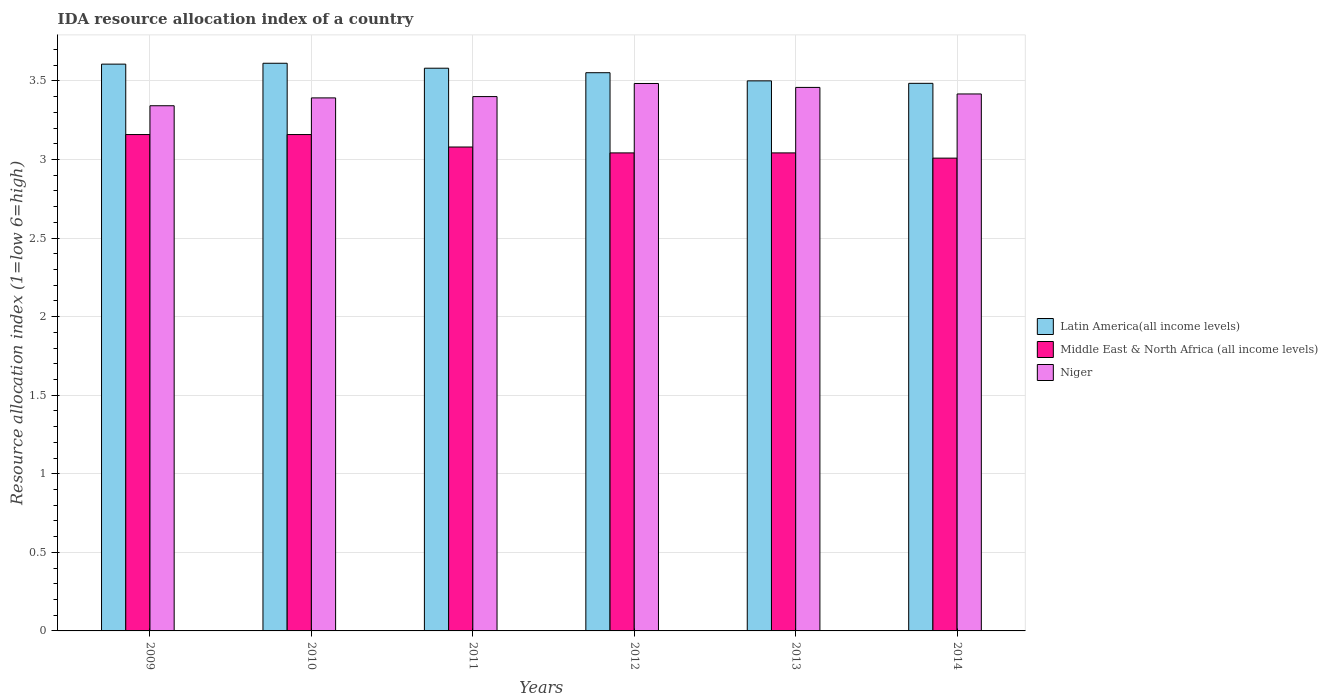How many groups of bars are there?
Offer a very short reply. 6. How many bars are there on the 1st tick from the right?
Provide a short and direct response. 3. What is the label of the 6th group of bars from the left?
Your response must be concise. 2014. In how many cases, is the number of bars for a given year not equal to the number of legend labels?
Ensure brevity in your answer.  0. What is the IDA resource allocation index in Middle East & North Africa (all income levels) in 2010?
Offer a terse response. 3.16. Across all years, what is the maximum IDA resource allocation index in Latin America(all income levels)?
Your answer should be very brief. 3.61. Across all years, what is the minimum IDA resource allocation index in Middle East & North Africa (all income levels)?
Ensure brevity in your answer.  3.01. In which year was the IDA resource allocation index in Latin America(all income levels) maximum?
Provide a succinct answer. 2010. In which year was the IDA resource allocation index in Niger minimum?
Ensure brevity in your answer.  2009. What is the total IDA resource allocation index in Niger in the graph?
Make the answer very short. 20.49. What is the difference between the IDA resource allocation index in Middle East & North Africa (all income levels) in 2009 and that in 2011?
Ensure brevity in your answer.  0.08. What is the difference between the IDA resource allocation index in Latin America(all income levels) in 2014 and the IDA resource allocation index in Middle East & North Africa (all income levels) in 2012?
Make the answer very short. 0.44. What is the average IDA resource allocation index in Middle East & North Africa (all income levels) per year?
Your answer should be very brief. 3.08. In the year 2013, what is the difference between the IDA resource allocation index in Latin America(all income levels) and IDA resource allocation index in Niger?
Keep it short and to the point. 0.04. What is the ratio of the IDA resource allocation index in Niger in 2011 to that in 2012?
Make the answer very short. 0.98. Is the IDA resource allocation index in Niger in 2010 less than that in 2011?
Make the answer very short. Yes. What is the difference between the highest and the second highest IDA resource allocation index in Latin America(all income levels)?
Make the answer very short. 0.01. What is the difference between the highest and the lowest IDA resource allocation index in Niger?
Provide a short and direct response. 0.14. In how many years, is the IDA resource allocation index in Niger greater than the average IDA resource allocation index in Niger taken over all years?
Provide a short and direct response. 3. Is the sum of the IDA resource allocation index in Niger in 2009 and 2013 greater than the maximum IDA resource allocation index in Latin America(all income levels) across all years?
Make the answer very short. Yes. What does the 1st bar from the left in 2009 represents?
Give a very brief answer. Latin America(all income levels). What does the 2nd bar from the right in 2013 represents?
Give a very brief answer. Middle East & North Africa (all income levels). How many years are there in the graph?
Provide a short and direct response. 6. Are the values on the major ticks of Y-axis written in scientific E-notation?
Keep it short and to the point. No. Does the graph contain any zero values?
Give a very brief answer. No. Where does the legend appear in the graph?
Provide a short and direct response. Center right. How many legend labels are there?
Provide a succinct answer. 3. How are the legend labels stacked?
Your response must be concise. Vertical. What is the title of the graph?
Offer a very short reply. IDA resource allocation index of a country. Does "Sub-Saharan Africa (all income levels)" appear as one of the legend labels in the graph?
Offer a terse response. No. What is the label or title of the Y-axis?
Your answer should be compact. Resource allocation index (1=low 6=high). What is the Resource allocation index (1=low 6=high) in Latin America(all income levels) in 2009?
Your response must be concise. 3.61. What is the Resource allocation index (1=low 6=high) in Middle East & North Africa (all income levels) in 2009?
Offer a very short reply. 3.16. What is the Resource allocation index (1=low 6=high) of Niger in 2009?
Offer a terse response. 3.34. What is the Resource allocation index (1=low 6=high) in Latin America(all income levels) in 2010?
Keep it short and to the point. 3.61. What is the Resource allocation index (1=low 6=high) of Middle East & North Africa (all income levels) in 2010?
Your response must be concise. 3.16. What is the Resource allocation index (1=low 6=high) in Niger in 2010?
Give a very brief answer. 3.39. What is the Resource allocation index (1=low 6=high) in Latin America(all income levels) in 2011?
Offer a terse response. 3.58. What is the Resource allocation index (1=low 6=high) of Middle East & North Africa (all income levels) in 2011?
Make the answer very short. 3.08. What is the Resource allocation index (1=low 6=high) of Niger in 2011?
Your response must be concise. 3.4. What is the Resource allocation index (1=low 6=high) of Latin America(all income levels) in 2012?
Provide a succinct answer. 3.55. What is the Resource allocation index (1=low 6=high) of Middle East & North Africa (all income levels) in 2012?
Provide a short and direct response. 3.04. What is the Resource allocation index (1=low 6=high) in Niger in 2012?
Offer a terse response. 3.48. What is the Resource allocation index (1=low 6=high) in Middle East & North Africa (all income levels) in 2013?
Offer a very short reply. 3.04. What is the Resource allocation index (1=low 6=high) of Niger in 2013?
Your answer should be compact. 3.46. What is the Resource allocation index (1=low 6=high) in Latin America(all income levels) in 2014?
Keep it short and to the point. 3.48. What is the Resource allocation index (1=low 6=high) in Middle East & North Africa (all income levels) in 2014?
Your response must be concise. 3.01. What is the Resource allocation index (1=low 6=high) of Niger in 2014?
Keep it short and to the point. 3.42. Across all years, what is the maximum Resource allocation index (1=low 6=high) in Latin America(all income levels)?
Make the answer very short. 3.61. Across all years, what is the maximum Resource allocation index (1=low 6=high) in Middle East & North Africa (all income levels)?
Provide a short and direct response. 3.16. Across all years, what is the maximum Resource allocation index (1=low 6=high) of Niger?
Offer a terse response. 3.48. Across all years, what is the minimum Resource allocation index (1=low 6=high) in Latin America(all income levels)?
Your answer should be compact. 3.48. Across all years, what is the minimum Resource allocation index (1=low 6=high) in Middle East & North Africa (all income levels)?
Your response must be concise. 3.01. Across all years, what is the minimum Resource allocation index (1=low 6=high) of Niger?
Your response must be concise. 3.34. What is the total Resource allocation index (1=low 6=high) in Latin America(all income levels) in the graph?
Your answer should be compact. 21.34. What is the total Resource allocation index (1=low 6=high) of Middle East & North Africa (all income levels) in the graph?
Offer a terse response. 18.49. What is the total Resource allocation index (1=low 6=high) in Niger in the graph?
Keep it short and to the point. 20.49. What is the difference between the Resource allocation index (1=low 6=high) in Latin America(all income levels) in 2009 and that in 2010?
Keep it short and to the point. -0.01. What is the difference between the Resource allocation index (1=low 6=high) in Middle East & North Africa (all income levels) in 2009 and that in 2010?
Offer a terse response. 0. What is the difference between the Resource allocation index (1=low 6=high) in Niger in 2009 and that in 2010?
Ensure brevity in your answer.  -0.05. What is the difference between the Resource allocation index (1=low 6=high) in Latin America(all income levels) in 2009 and that in 2011?
Provide a succinct answer. 0.03. What is the difference between the Resource allocation index (1=low 6=high) of Middle East & North Africa (all income levels) in 2009 and that in 2011?
Your response must be concise. 0.08. What is the difference between the Resource allocation index (1=low 6=high) in Niger in 2009 and that in 2011?
Give a very brief answer. -0.06. What is the difference between the Resource allocation index (1=low 6=high) in Latin America(all income levels) in 2009 and that in 2012?
Give a very brief answer. 0.05. What is the difference between the Resource allocation index (1=low 6=high) in Middle East & North Africa (all income levels) in 2009 and that in 2012?
Offer a terse response. 0.12. What is the difference between the Resource allocation index (1=low 6=high) in Niger in 2009 and that in 2012?
Your response must be concise. -0.14. What is the difference between the Resource allocation index (1=low 6=high) of Latin America(all income levels) in 2009 and that in 2013?
Ensure brevity in your answer.  0.11. What is the difference between the Resource allocation index (1=low 6=high) in Middle East & North Africa (all income levels) in 2009 and that in 2013?
Provide a short and direct response. 0.12. What is the difference between the Resource allocation index (1=low 6=high) of Niger in 2009 and that in 2013?
Your answer should be very brief. -0.12. What is the difference between the Resource allocation index (1=low 6=high) of Latin America(all income levels) in 2009 and that in 2014?
Your answer should be compact. 0.12. What is the difference between the Resource allocation index (1=low 6=high) of Middle East & North Africa (all income levels) in 2009 and that in 2014?
Offer a very short reply. 0.15. What is the difference between the Resource allocation index (1=low 6=high) in Niger in 2009 and that in 2014?
Offer a very short reply. -0.07. What is the difference between the Resource allocation index (1=low 6=high) in Latin America(all income levels) in 2010 and that in 2011?
Make the answer very short. 0.03. What is the difference between the Resource allocation index (1=low 6=high) of Middle East & North Africa (all income levels) in 2010 and that in 2011?
Give a very brief answer. 0.08. What is the difference between the Resource allocation index (1=low 6=high) in Niger in 2010 and that in 2011?
Give a very brief answer. -0.01. What is the difference between the Resource allocation index (1=low 6=high) of Latin America(all income levels) in 2010 and that in 2012?
Provide a succinct answer. 0.06. What is the difference between the Resource allocation index (1=low 6=high) of Middle East & North Africa (all income levels) in 2010 and that in 2012?
Make the answer very short. 0.12. What is the difference between the Resource allocation index (1=low 6=high) of Niger in 2010 and that in 2012?
Your response must be concise. -0.09. What is the difference between the Resource allocation index (1=low 6=high) in Latin America(all income levels) in 2010 and that in 2013?
Ensure brevity in your answer.  0.11. What is the difference between the Resource allocation index (1=low 6=high) in Middle East & North Africa (all income levels) in 2010 and that in 2013?
Ensure brevity in your answer.  0.12. What is the difference between the Resource allocation index (1=low 6=high) in Niger in 2010 and that in 2013?
Your response must be concise. -0.07. What is the difference between the Resource allocation index (1=low 6=high) in Latin America(all income levels) in 2010 and that in 2014?
Your response must be concise. 0.13. What is the difference between the Resource allocation index (1=low 6=high) in Middle East & North Africa (all income levels) in 2010 and that in 2014?
Give a very brief answer. 0.15. What is the difference between the Resource allocation index (1=low 6=high) in Niger in 2010 and that in 2014?
Your response must be concise. -0.03. What is the difference between the Resource allocation index (1=low 6=high) of Latin America(all income levels) in 2011 and that in 2012?
Your answer should be compact. 0.03. What is the difference between the Resource allocation index (1=low 6=high) of Middle East & North Africa (all income levels) in 2011 and that in 2012?
Offer a very short reply. 0.04. What is the difference between the Resource allocation index (1=low 6=high) in Niger in 2011 and that in 2012?
Your answer should be very brief. -0.08. What is the difference between the Resource allocation index (1=low 6=high) in Latin America(all income levels) in 2011 and that in 2013?
Offer a terse response. 0.08. What is the difference between the Resource allocation index (1=low 6=high) of Middle East & North Africa (all income levels) in 2011 and that in 2013?
Your answer should be compact. 0.04. What is the difference between the Resource allocation index (1=low 6=high) in Niger in 2011 and that in 2013?
Your answer should be very brief. -0.06. What is the difference between the Resource allocation index (1=low 6=high) in Latin America(all income levels) in 2011 and that in 2014?
Provide a succinct answer. 0.1. What is the difference between the Resource allocation index (1=low 6=high) of Middle East & North Africa (all income levels) in 2011 and that in 2014?
Ensure brevity in your answer.  0.07. What is the difference between the Resource allocation index (1=low 6=high) of Niger in 2011 and that in 2014?
Provide a succinct answer. -0.02. What is the difference between the Resource allocation index (1=low 6=high) in Latin America(all income levels) in 2012 and that in 2013?
Give a very brief answer. 0.05. What is the difference between the Resource allocation index (1=low 6=high) in Niger in 2012 and that in 2013?
Your answer should be compact. 0.03. What is the difference between the Resource allocation index (1=low 6=high) in Latin America(all income levels) in 2012 and that in 2014?
Make the answer very short. 0.07. What is the difference between the Resource allocation index (1=low 6=high) of Middle East & North Africa (all income levels) in 2012 and that in 2014?
Your response must be concise. 0.03. What is the difference between the Resource allocation index (1=low 6=high) of Niger in 2012 and that in 2014?
Offer a terse response. 0.07. What is the difference between the Resource allocation index (1=low 6=high) in Latin America(all income levels) in 2013 and that in 2014?
Keep it short and to the point. 0.02. What is the difference between the Resource allocation index (1=low 6=high) of Middle East & North Africa (all income levels) in 2013 and that in 2014?
Your answer should be compact. 0.03. What is the difference between the Resource allocation index (1=low 6=high) in Niger in 2013 and that in 2014?
Your answer should be very brief. 0.04. What is the difference between the Resource allocation index (1=low 6=high) of Latin America(all income levels) in 2009 and the Resource allocation index (1=low 6=high) of Middle East & North Africa (all income levels) in 2010?
Make the answer very short. 0.45. What is the difference between the Resource allocation index (1=low 6=high) in Latin America(all income levels) in 2009 and the Resource allocation index (1=low 6=high) in Niger in 2010?
Ensure brevity in your answer.  0.21. What is the difference between the Resource allocation index (1=low 6=high) of Middle East & North Africa (all income levels) in 2009 and the Resource allocation index (1=low 6=high) of Niger in 2010?
Keep it short and to the point. -0.23. What is the difference between the Resource allocation index (1=low 6=high) in Latin America(all income levels) in 2009 and the Resource allocation index (1=low 6=high) in Middle East & North Africa (all income levels) in 2011?
Make the answer very short. 0.53. What is the difference between the Resource allocation index (1=low 6=high) of Latin America(all income levels) in 2009 and the Resource allocation index (1=low 6=high) of Niger in 2011?
Your answer should be very brief. 0.21. What is the difference between the Resource allocation index (1=low 6=high) in Middle East & North Africa (all income levels) in 2009 and the Resource allocation index (1=low 6=high) in Niger in 2011?
Make the answer very short. -0.24. What is the difference between the Resource allocation index (1=low 6=high) in Latin America(all income levels) in 2009 and the Resource allocation index (1=low 6=high) in Middle East & North Africa (all income levels) in 2012?
Offer a terse response. 0.56. What is the difference between the Resource allocation index (1=low 6=high) of Latin America(all income levels) in 2009 and the Resource allocation index (1=low 6=high) of Niger in 2012?
Offer a terse response. 0.12. What is the difference between the Resource allocation index (1=low 6=high) of Middle East & North Africa (all income levels) in 2009 and the Resource allocation index (1=low 6=high) of Niger in 2012?
Make the answer very short. -0.33. What is the difference between the Resource allocation index (1=low 6=high) of Latin America(all income levels) in 2009 and the Resource allocation index (1=low 6=high) of Middle East & North Africa (all income levels) in 2013?
Offer a terse response. 0.56. What is the difference between the Resource allocation index (1=low 6=high) in Latin America(all income levels) in 2009 and the Resource allocation index (1=low 6=high) in Niger in 2013?
Make the answer very short. 0.15. What is the difference between the Resource allocation index (1=low 6=high) in Latin America(all income levels) in 2009 and the Resource allocation index (1=low 6=high) in Middle East & North Africa (all income levels) in 2014?
Offer a very short reply. 0.6. What is the difference between the Resource allocation index (1=low 6=high) in Latin America(all income levels) in 2009 and the Resource allocation index (1=low 6=high) in Niger in 2014?
Offer a terse response. 0.19. What is the difference between the Resource allocation index (1=low 6=high) of Middle East & North Africa (all income levels) in 2009 and the Resource allocation index (1=low 6=high) of Niger in 2014?
Your answer should be very brief. -0.26. What is the difference between the Resource allocation index (1=low 6=high) of Latin America(all income levels) in 2010 and the Resource allocation index (1=low 6=high) of Middle East & North Africa (all income levels) in 2011?
Your answer should be compact. 0.53. What is the difference between the Resource allocation index (1=low 6=high) of Latin America(all income levels) in 2010 and the Resource allocation index (1=low 6=high) of Niger in 2011?
Offer a terse response. 0.21. What is the difference between the Resource allocation index (1=low 6=high) of Middle East & North Africa (all income levels) in 2010 and the Resource allocation index (1=low 6=high) of Niger in 2011?
Your response must be concise. -0.24. What is the difference between the Resource allocation index (1=low 6=high) in Latin America(all income levels) in 2010 and the Resource allocation index (1=low 6=high) in Middle East & North Africa (all income levels) in 2012?
Make the answer very short. 0.57. What is the difference between the Resource allocation index (1=low 6=high) of Latin America(all income levels) in 2010 and the Resource allocation index (1=low 6=high) of Niger in 2012?
Offer a terse response. 0.13. What is the difference between the Resource allocation index (1=low 6=high) in Middle East & North Africa (all income levels) in 2010 and the Resource allocation index (1=low 6=high) in Niger in 2012?
Give a very brief answer. -0.33. What is the difference between the Resource allocation index (1=low 6=high) in Latin America(all income levels) in 2010 and the Resource allocation index (1=low 6=high) in Middle East & North Africa (all income levels) in 2013?
Your answer should be compact. 0.57. What is the difference between the Resource allocation index (1=low 6=high) of Latin America(all income levels) in 2010 and the Resource allocation index (1=low 6=high) of Niger in 2013?
Your response must be concise. 0.15. What is the difference between the Resource allocation index (1=low 6=high) in Latin America(all income levels) in 2010 and the Resource allocation index (1=low 6=high) in Middle East & North Africa (all income levels) in 2014?
Give a very brief answer. 0.6. What is the difference between the Resource allocation index (1=low 6=high) of Latin America(all income levels) in 2010 and the Resource allocation index (1=low 6=high) of Niger in 2014?
Keep it short and to the point. 0.2. What is the difference between the Resource allocation index (1=low 6=high) in Middle East & North Africa (all income levels) in 2010 and the Resource allocation index (1=low 6=high) in Niger in 2014?
Provide a short and direct response. -0.26. What is the difference between the Resource allocation index (1=low 6=high) of Latin America(all income levels) in 2011 and the Resource allocation index (1=low 6=high) of Middle East & North Africa (all income levels) in 2012?
Your response must be concise. 0.54. What is the difference between the Resource allocation index (1=low 6=high) in Latin America(all income levels) in 2011 and the Resource allocation index (1=low 6=high) in Niger in 2012?
Your answer should be compact. 0.1. What is the difference between the Resource allocation index (1=low 6=high) of Middle East & North Africa (all income levels) in 2011 and the Resource allocation index (1=low 6=high) of Niger in 2012?
Give a very brief answer. -0.4. What is the difference between the Resource allocation index (1=low 6=high) of Latin America(all income levels) in 2011 and the Resource allocation index (1=low 6=high) of Middle East & North Africa (all income levels) in 2013?
Ensure brevity in your answer.  0.54. What is the difference between the Resource allocation index (1=low 6=high) of Latin America(all income levels) in 2011 and the Resource allocation index (1=low 6=high) of Niger in 2013?
Ensure brevity in your answer.  0.12. What is the difference between the Resource allocation index (1=low 6=high) in Middle East & North Africa (all income levels) in 2011 and the Resource allocation index (1=low 6=high) in Niger in 2013?
Keep it short and to the point. -0.38. What is the difference between the Resource allocation index (1=low 6=high) in Latin America(all income levels) in 2011 and the Resource allocation index (1=low 6=high) in Middle East & North Africa (all income levels) in 2014?
Give a very brief answer. 0.57. What is the difference between the Resource allocation index (1=low 6=high) of Latin America(all income levels) in 2011 and the Resource allocation index (1=low 6=high) of Niger in 2014?
Provide a succinct answer. 0.16. What is the difference between the Resource allocation index (1=low 6=high) in Middle East & North Africa (all income levels) in 2011 and the Resource allocation index (1=low 6=high) in Niger in 2014?
Give a very brief answer. -0.34. What is the difference between the Resource allocation index (1=low 6=high) in Latin America(all income levels) in 2012 and the Resource allocation index (1=low 6=high) in Middle East & North Africa (all income levels) in 2013?
Keep it short and to the point. 0.51. What is the difference between the Resource allocation index (1=low 6=high) of Latin America(all income levels) in 2012 and the Resource allocation index (1=low 6=high) of Niger in 2013?
Provide a succinct answer. 0.09. What is the difference between the Resource allocation index (1=low 6=high) of Middle East & North Africa (all income levels) in 2012 and the Resource allocation index (1=low 6=high) of Niger in 2013?
Your answer should be compact. -0.42. What is the difference between the Resource allocation index (1=low 6=high) in Latin America(all income levels) in 2012 and the Resource allocation index (1=low 6=high) in Middle East & North Africa (all income levels) in 2014?
Your response must be concise. 0.54. What is the difference between the Resource allocation index (1=low 6=high) of Latin America(all income levels) in 2012 and the Resource allocation index (1=low 6=high) of Niger in 2014?
Ensure brevity in your answer.  0.14. What is the difference between the Resource allocation index (1=low 6=high) in Middle East & North Africa (all income levels) in 2012 and the Resource allocation index (1=low 6=high) in Niger in 2014?
Ensure brevity in your answer.  -0.38. What is the difference between the Resource allocation index (1=low 6=high) in Latin America(all income levels) in 2013 and the Resource allocation index (1=low 6=high) in Middle East & North Africa (all income levels) in 2014?
Provide a succinct answer. 0.49. What is the difference between the Resource allocation index (1=low 6=high) in Latin America(all income levels) in 2013 and the Resource allocation index (1=low 6=high) in Niger in 2014?
Provide a short and direct response. 0.08. What is the difference between the Resource allocation index (1=low 6=high) in Middle East & North Africa (all income levels) in 2013 and the Resource allocation index (1=low 6=high) in Niger in 2014?
Your answer should be compact. -0.38. What is the average Resource allocation index (1=low 6=high) in Latin America(all income levels) per year?
Keep it short and to the point. 3.56. What is the average Resource allocation index (1=low 6=high) in Middle East & North Africa (all income levels) per year?
Keep it short and to the point. 3.08. What is the average Resource allocation index (1=low 6=high) of Niger per year?
Your answer should be very brief. 3.42. In the year 2009, what is the difference between the Resource allocation index (1=low 6=high) of Latin America(all income levels) and Resource allocation index (1=low 6=high) of Middle East & North Africa (all income levels)?
Give a very brief answer. 0.45. In the year 2009, what is the difference between the Resource allocation index (1=low 6=high) in Latin America(all income levels) and Resource allocation index (1=low 6=high) in Niger?
Offer a very short reply. 0.26. In the year 2009, what is the difference between the Resource allocation index (1=low 6=high) of Middle East & North Africa (all income levels) and Resource allocation index (1=low 6=high) of Niger?
Offer a terse response. -0.18. In the year 2010, what is the difference between the Resource allocation index (1=low 6=high) of Latin America(all income levels) and Resource allocation index (1=low 6=high) of Middle East & North Africa (all income levels)?
Provide a succinct answer. 0.45. In the year 2010, what is the difference between the Resource allocation index (1=low 6=high) in Latin America(all income levels) and Resource allocation index (1=low 6=high) in Niger?
Ensure brevity in your answer.  0.22. In the year 2010, what is the difference between the Resource allocation index (1=low 6=high) of Middle East & North Africa (all income levels) and Resource allocation index (1=low 6=high) of Niger?
Provide a short and direct response. -0.23. In the year 2011, what is the difference between the Resource allocation index (1=low 6=high) of Latin America(all income levels) and Resource allocation index (1=low 6=high) of Middle East & North Africa (all income levels)?
Keep it short and to the point. 0.5. In the year 2011, what is the difference between the Resource allocation index (1=low 6=high) in Latin America(all income levels) and Resource allocation index (1=low 6=high) in Niger?
Provide a succinct answer. 0.18. In the year 2011, what is the difference between the Resource allocation index (1=low 6=high) in Middle East & North Africa (all income levels) and Resource allocation index (1=low 6=high) in Niger?
Your answer should be compact. -0.32. In the year 2012, what is the difference between the Resource allocation index (1=low 6=high) of Latin America(all income levels) and Resource allocation index (1=low 6=high) of Middle East & North Africa (all income levels)?
Provide a short and direct response. 0.51. In the year 2012, what is the difference between the Resource allocation index (1=low 6=high) in Latin America(all income levels) and Resource allocation index (1=low 6=high) in Niger?
Make the answer very short. 0.07. In the year 2012, what is the difference between the Resource allocation index (1=low 6=high) of Middle East & North Africa (all income levels) and Resource allocation index (1=low 6=high) of Niger?
Offer a terse response. -0.44. In the year 2013, what is the difference between the Resource allocation index (1=low 6=high) of Latin America(all income levels) and Resource allocation index (1=low 6=high) of Middle East & North Africa (all income levels)?
Ensure brevity in your answer.  0.46. In the year 2013, what is the difference between the Resource allocation index (1=low 6=high) in Latin America(all income levels) and Resource allocation index (1=low 6=high) in Niger?
Keep it short and to the point. 0.04. In the year 2013, what is the difference between the Resource allocation index (1=low 6=high) in Middle East & North Africa (all income levels) and Resource allocation index (1=low 6=high) in Niger?
Give a very brief answer. -0.42. In the year 2014, what is the difference between the Resource allocation index (1=low 6=high) in Latin America(all income levels) and Resource allocation index (1=low 6=high) in Middle East & North Africa (all income levels)?
Provide a short and direct response. 0.48. In the year 2014, what is the difference between the Resource allocation index (1=low 6=high) of Latin America(all income levels) and Resource allocation index (1=low 6=high) of Niger?
Ensure brevity in your answer.  0.07. In the year 2014, what is the difference between the Resource allocation index (1=low 6=high) of Middle East & North Africa (all income levels) and Resource allocation index (1=low 6=high) of Niger?
Offer a terse response. -0.41. What is the ratio of the Resource allocation index (1=low 6=high) in Middle East & North Africa (all income levels) in 2009 to that in 2010?
Provide a short and direct response. 1. What is the ratio of the Resource allocation index (1=low 6=high) in Niger in 2009 to that in 2010?
Provide a succinct answer. 0.99. What is the ratio of the Resource allocation index (1=low 6=high) of Middle East & North Africa (all income levels) in 2009 to that in 2011?
Your answer should be very brief. 1.03. What is the ratio of the Resource allocation index (1=low 6=high) in Niger in 2009 to that in 2011?
Give a very brief answer. 0.98. What is the ratio of the Resource allocation index (1=low 6=high) in Latin America(all income levels) in 2009 to that in 2012?
Your answer should be very brief. 1.02. What is the ratio of the Resource allocation index (1=low 6=high) in Middle East & North Africa (all income levels) in 2009 to that in 2012?
Your answer should be very brief. 1.04. What is the ratio of the Resource allocation index (1=low 6=high) in Niger in 2009 to that in 2012?
Offer a terse response. 0.96. What is the ratio of the Resource allocation index (1=low 6=high) in Latin America(all income levels) in 2009 to that in 2013?
Keep it short and to the point. 1.03. What is the ratio of the Resource allocation index (1=low 6=high) in Middle East & North Africa (all income levels) in 2009 to that in 2013?
Give a very brief answer. 1.04. What is the ratio of the Resource allocation index (1=low 6=high) of Niger in 2009 to that in 2013?
Provide a succinct answer. 0.97. What is the ratio of the Resource allocation index (1=low 6=high) of Latin America(all income levels) in 2009 to that in 2014?
Offer a terse response. 1.04. What is the ratio of the Resource allocation index (1=low 6=high) of Middle East & North Africa (all income levels) in 2009 to that in 2014?
Provide a short and direct response. 1.05. What is the ratio of the Resource allocation index (1=low 6=high) in Latin America(all income levels) in 2010 to that in 2011?
Give a very brief answer. 1.01. What is the ratio of the Resource allocation index (1=low 6=high) of Middle East & North Africa (all income levels) in 2010 to that in 2011?
Offer a very short reply. 1.03. What is the ratio of the Resource allocation index (1=low 6=high) in Niger in 2010 to that in 2011?
Ensure brevity in your answer.  1. What is the ratio of the Resource allocation index (1=low 6=high) of Latin America(all income levels) in 2010 to that in 2012?
Keep it short and to the point. 1.02. What is the ratio of the Resource allocation index (1=low 6=high) of Middle East & North Africa (all income levels) in 2010 to that in 2012?
Provide a short and direct response. 1.04. What is the ratio of the Resource allocation index (1=low 6=high) in Niger in 2010 to that in 2012?
Provide a succinct answer. 0.97. What is the ratio of the Resource allocation index (1=low 6=high) of Latin America(all income levels) in 2010 to that in 2013?
Ensure brevity in your answer.  1.03. What is the ratio of the Resource allocation index (1=low 6=high) in Middle East & North Africa (all income levels) in 2010 to that in 2013?
Your response must be concise. 1.04. What is the ratio of the Resource allocation index (1=low 6=high) of Niger in 2010 to that in 2013?
Offer a very short reply. 0.98. What is the ratio of the Resource allocation index (1=low 6=high) in Latin America(all income levels) in 2010 to that in 2014?
Your answer should be very brief. 1.04. What is the ratio of the Resource allocation index (1=low 6=high) of Middle East & North Africa (all income levels) in 2010 to that in 2014?
Your response must be concise. 1.05. What is the ratio of the Resource allocation index (1=low 6=high) in Latin America(all income levels) in 2011 to that in 2012?
Give a very brief answer. 1.01. What is the ratio of the Resource allocation index (1=low 6=high) in Middle East & North Africa (all income levels) in 2011 to that in 2012?
Make the answer very short. 1.01. What is the ratio of the Resource allocation index (1=low 6=high) of Niger in 2011 to that in 2012?
Your answer should be very brief. 0.98. What is the ratio of the Resource allocation index (1=low 6=high) of Middle East & North Africa (all income levels) in 2011 to that in 2013?
Your answer should be very brief. 1.01. What is the ratio of the Resource allocation index (1=low 6=high) in Niger in 2011 to that in 2013?
Provide a short and direct response. 0.98. What is the ratio of the Resource allocation index (1=low 6=high) of Latin America(all income levels) in 2011 to that in 2014?
Provide a short and direct response. 1.03. What is the ratio of the Resource allocation index (1=low 6=high) in Middle East & North Africa (all income levels) in 2011 to that in 2014?
Your answer should be very brief. 1.02. What is the ratio of the Resource allocation index (1=low 6=high) in Latin America(all income levels) in 2012 to that in 2013?
Your response must be concise. 1.01. What is the ratio of the Resource allocation index (1=low 6=high) in Middle East & North Africa (all income levels) in 2012 to that in 2013?
Provide a short and direct response. 1. What is the ratio of the Resource allocation index (1=low 6=high) in Niger in 2012 to that in 2013?
Provide a succinct answer. 1.01. What is the ratio of the Resource allocation index (1=low 6=high) of Latin America(all income levels) in 2012 to that in 2014?
Make the answer very short. 1.02. What is the ratio of the Resource allocation index (1=low 6=high) of Middle East & North Africa (all income levels) in 2012 to that in 2014?
Make the answer very short. 1.01. What is the ratio of the Resource allocation index (1=low 6=high) in Niger in 2012 to that in 2014?
Your answer should be compact. 1.02. What is the ratio of the Resource allocation index (1=low 6=high) of Middle East & North Africa (all income levels) in 2013 to that in 2014?
Offer a terse response. 1.01. What is the ratio of the Resource allocation index (1=low 6=high) in Niger in 2013 to that in 2014?
Provide a short and direct response. 1.01. What is the difference between the highest and the second highest Resource allocation index (1=low 6=high) in Latin America(all income levels)?
Your response must be concise. 0.01. What is the difference between the highest and the second highest Resource allocation index (1=low 6=high) in Middle East & North Africa (all income levels)?
Your response must be concise. 0. What is the difference between the highest and the second highest Resource allocation index (1=low 6=high) in Niger?
Your response must be concise. 0.03. What is the difference between the highest and the lowest Resource allocation index (1=low 6=high) of Latin America(all income levels)?
Your answer should be very brief. 0.13. What is the difference between the highest and the lowest Resource allocation index (1=low 6=high) of Middle East & North Africa (all income levels)?
Provide a succinct answer. 0.15. What is the difference between the highest and the lowest Resource allocation index (1=low 6=high) in Niger?
Make the answer very short. 0.14. 